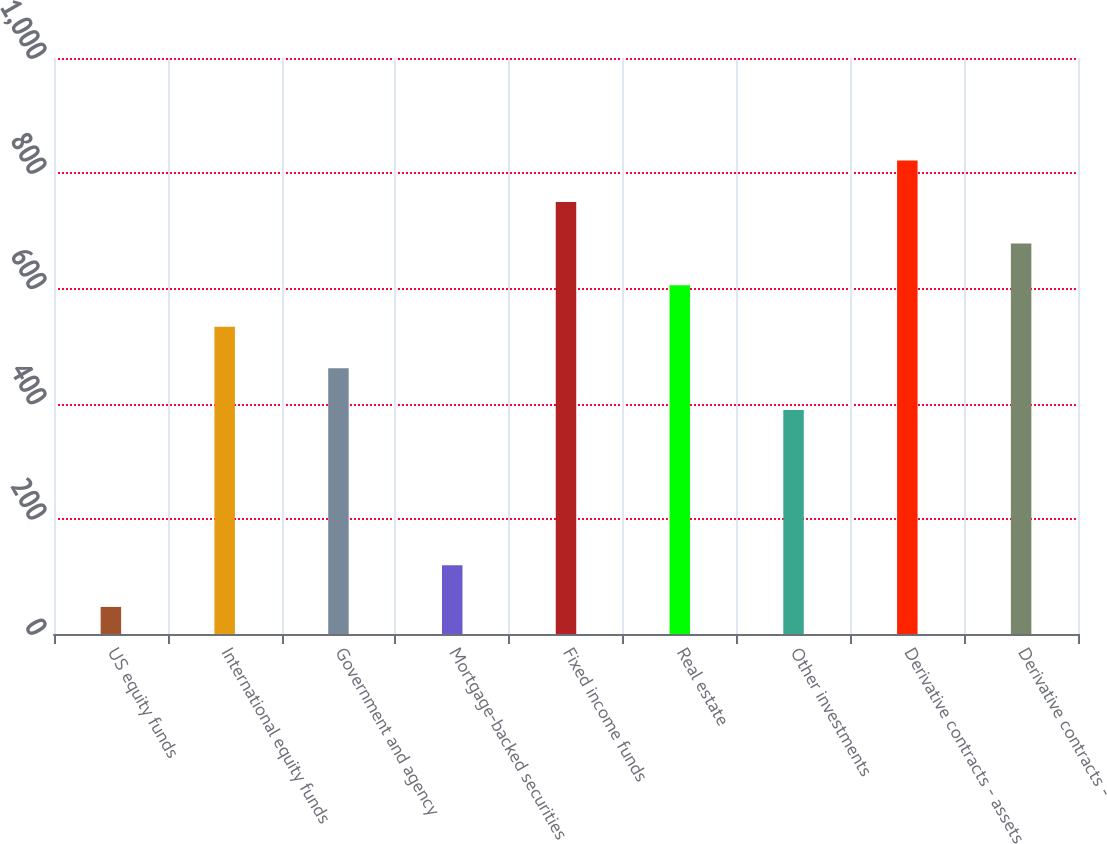Convert chart to OTSL. <chart><loc_0><loc_0><loc_500><loc_500><bar_chart><fcel>US equity funds<fcel>International equity funds<fcel>Government and agency<fcel>Mortgage-backed securities<fcel>Fixed income funds<fcel>Real estate<fcel>Other investments<fcel>Derivative contracts - assets<fcel>Derivative contracts -<nl><fcel>47<fcel>533.4<fcel>461.2<fcel>119.2<fcel>750<fcel>605.6<fcel>389<fcel>822.2<fcel>677.8<nl></chart> 